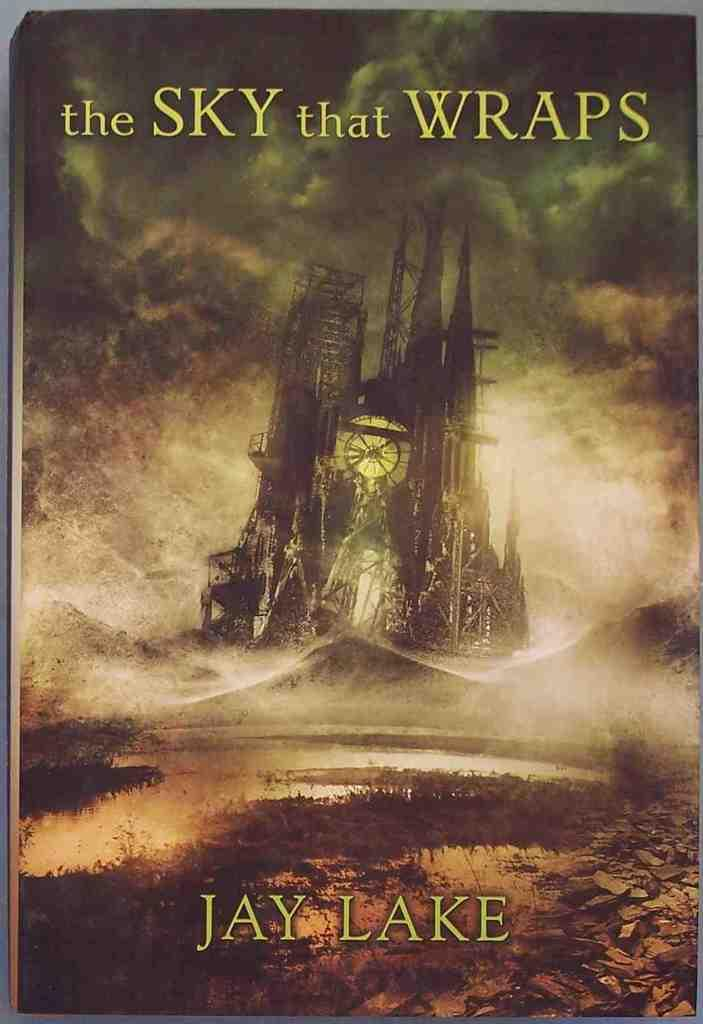<image>
Create a compact narrative representing the image presented. The cover of the novel "A Sky That Wraps" by Jay Lake. 